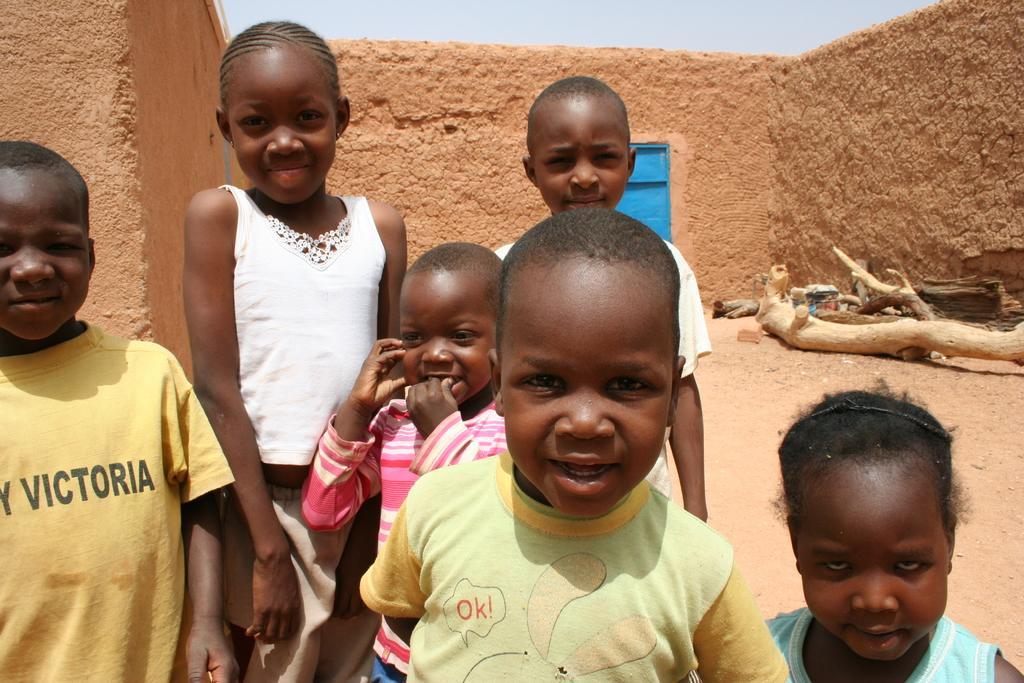Please provide a concise description of this image. In this image there are kids standing and smiling, there are branches, sand walls, and in the background there is sky. 